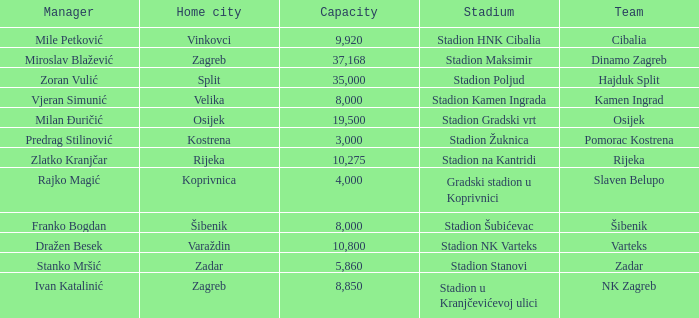What team has a home city of Velika? Kamen Ingrad. 